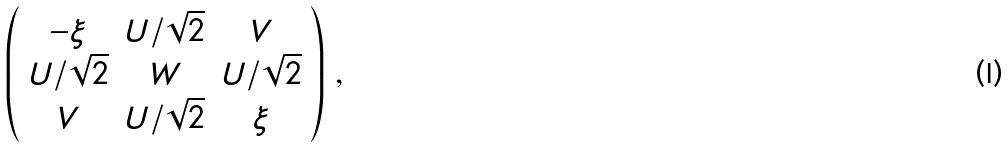Convert formula to latex. <formula><loc_0><loc_0><loc_500><loc_500>\left ( \begin{array} { c c c } - \xi & U / \sqrt { 2 } & V \\ U / \sqrt { 2 } & W & U / \sqrt { 2 } \\ V & U / \sqrt { 2 } & \xi \end{array} \right ) \, ,</formula> 